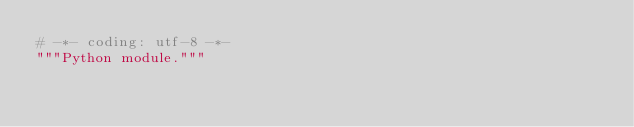<code> <loc_0><loc_0><loc_500><loc_500><_Python_># -*- coding: utf-8 -*-
"""Python module."""
</code> 